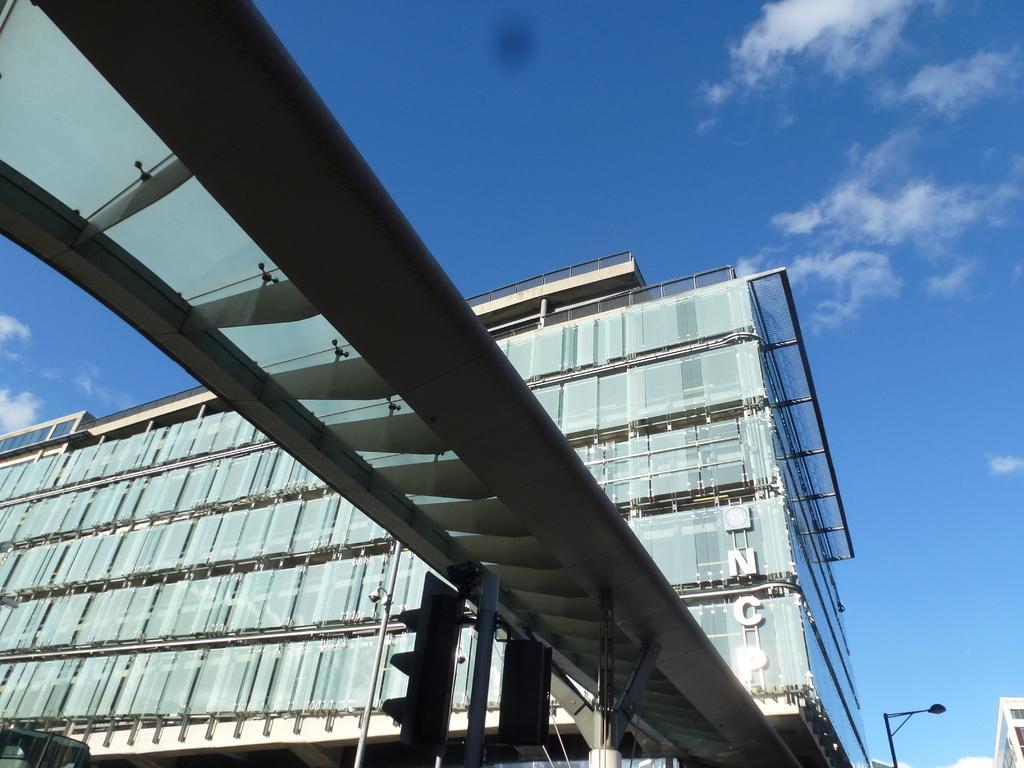Describe this image in one or two sentences. In the center of the image we can see building and traffic signals. In the background we can see sky and clouds. 